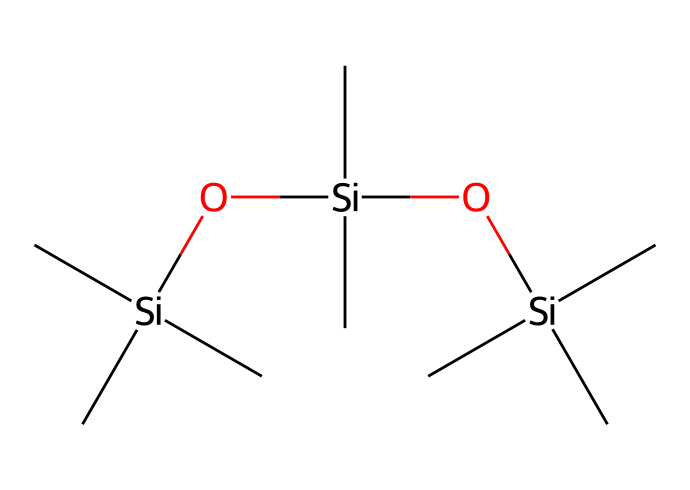What is the molecular formula of this chemical? The SMILES representation indicates the presence of silicon (Si), carbon (C), and oxygen (O) atoms. By counting the atoms from the structure represented, we can derive the molecular formula. There are 9 carbon atoms, 3 silicon atoms, and 2 oxygen atoms.
Answer: C9H30O2Si3 How many silicon atoms are present in the chemical structure? In the SMILES representation, silicon (Si) is indicated at three separate locations. Thus, the count of Si atoms in the structure is three.
Answer: 3 What type of chemical bonding is primarily present in this molecule? The structure includes silicon-to-carbon bonds and silicon-to-oxygen bonds. Such bonding generally indicates covalent bonding, where atoms share electrons.
Answer: covalent How many total atoms are present in the molecule? By adding the counts of carbon, silicon, and oxygen atoms derived from the SMILES, we find 9 (C) + 3 (Si) + 2 (O) = 14 total atoms. Therefore, the total number of atoms in the molecule is fourteen.
Answer: 14 What is the role of the silicon atoms in this lubricant? The silicon atoms provide structural integrity and enhance the lubricant's properties, such as increasing stability and reducing friction. This happens due to the unique properties of siloxane bonds in lubrication applications.
Answer: structural integrity Is this chemical likely to be hydrophobic or hydrophilic? The presence of silicon-based compounds often leads to hydrophobic properties, meaning it would repel water. This behavior is due to the alkyl groups attached to the silicon atoms in its structure, reducing polarity.
Answer: hydrophobic 